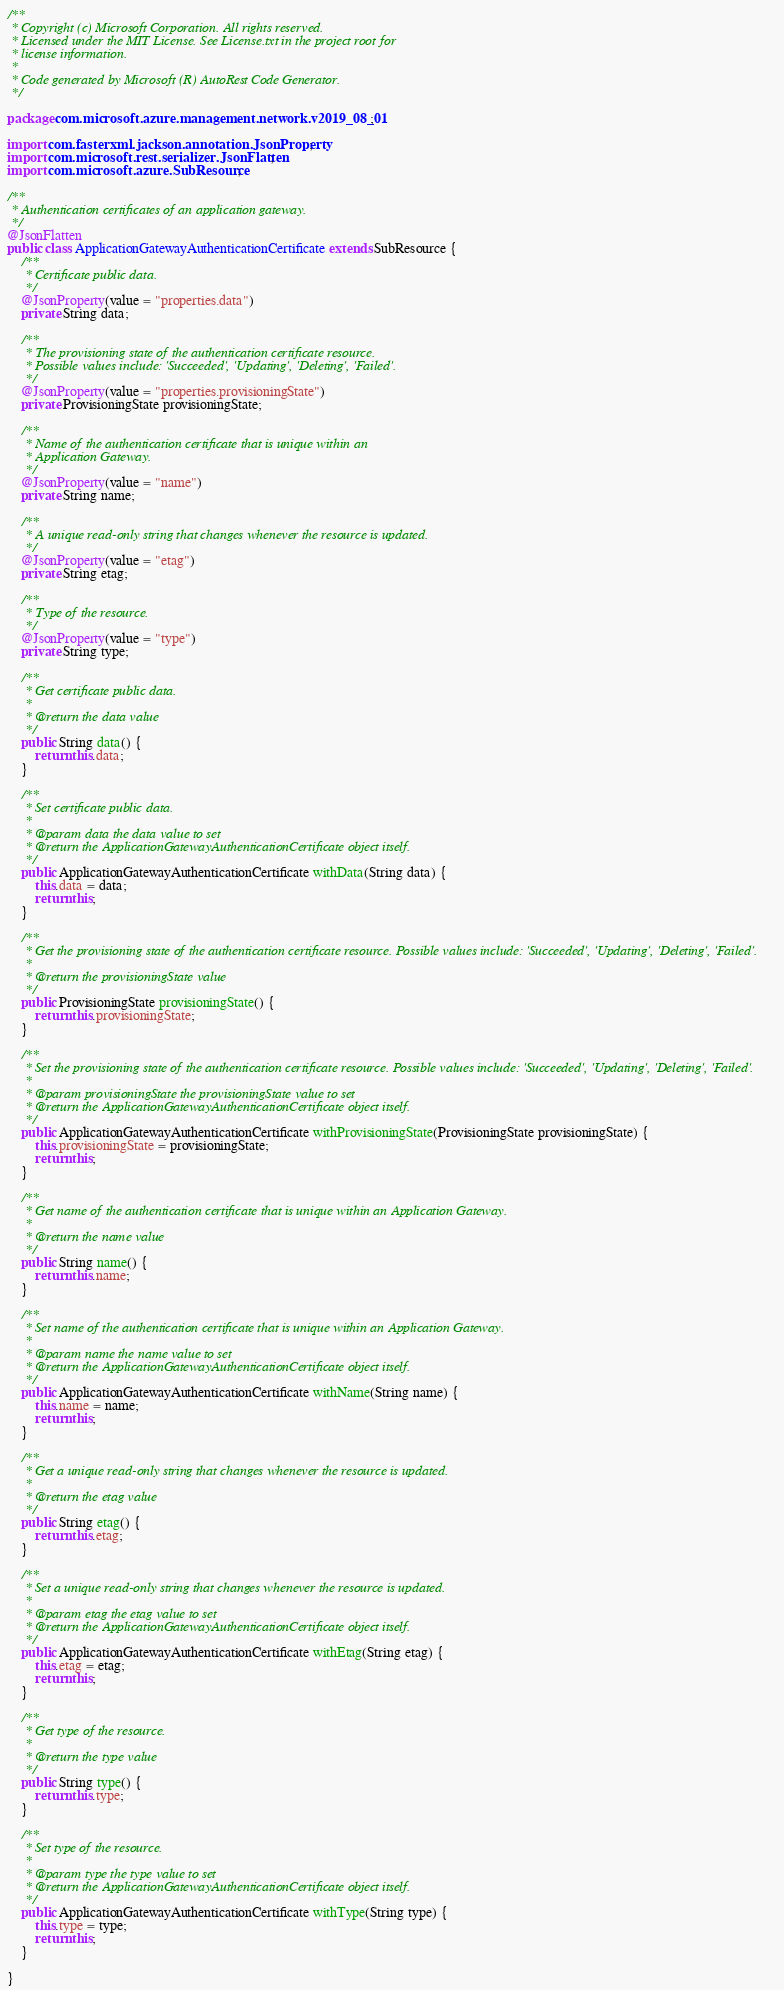<code> <loc_0><loc_0><loc_500><loc_500><_Java_>/**
 * Copyright (c) Microsoft Corporation. All rights reserved.
 * Licensed under the MIT License. See License.txt in the project root for
 * license information.
 *
 * Code generated by Microsoft (R) AutoRest Code Generator.
 */

package com.microsoft.azure.management.network.v2019_08_01;

import com.fasterxml.jackson.annotation.JsonProperty;
import com.microsoft.rest.serializer.JsonFlatten;
import com.microsoft.azure.SubResource;

/**
 * Authentication certificates of an application gateway.
 */
@JsonFlatten
public class ApplicationGatewayAuthenticationCertificate extends SubResource {
    /**
     * Certificate public data.
     */
    @JsonProperty(value = "properties.data")
    private String data;

    /**
     * The provisioning state of the authentication certificate resource.
     * Possible values include: 'Succeeded', 'Updating', 'Deleting', 'Failed'.
     */
    @JsonProperty(value = "properties.provisioningState")
    private ProvisioningState provisioningState;

    /**
     * Name of the authentication certificate that is unique within an
     * Application Gateway.
     */
    @JsonProperty(value = "name")
    private String name;

    /**
     * A unique read-only string that changes whenever the resource is updated.
     */
    @JsonProperty(value = "etag")
    private String etag;

    /**
     * Type of the resource.
     */
    @JsonProperty(value = "type")
    private String type;

    /**
     * Get certificate public data.
     *
     * @return the data value
     */
    public String data() {
        return this.data;
    }

    /**
     * Set certificate public data.
     *
     * @param data the data value to set
     * @return the ApplicationGatewayAuthenticationCertificate object itself.
     */
    public ApplicationGatewayAuthenticationCertificate withData(String data) {
        this.data = data;
        return this;
    }

    /**
     * Get the provisioning state of the authentication certificate resource. Possible values include: 'Succeeded', 'Updating', 'Deleting', 'Failed'.
     *
     * @return the provisioningState value
     */
    public ProvisioningState provisioningState() {
        return this.provisioningState;
    }

    /**
     * Set the provisioning state of the authentication certificate resource. Possible values include: 'Succeeded', 'Updating', 'Deleting', 'Failed'.
     *
     * @param provisioningState the provisioningState value to set
     * @return the ApplicationGatewayAuthenticationCertificate object itself.
     */
    public ApplicationGatewayAuthenticationCertificate withProvisioningState(ProvisioningState provisioningState) {
        this.provisioningState = provisioningState;
        return this;
    }

    /**
     * Get name of the authentication certificate that is unique within an Application Gateway.
     *
     * @return the name value
     */
    public String name() {
        return this.name;
    }

    /**
     * Set name of the authentication certificate that is unique within an Application Gateway.
     *
     * @param name the name value to set
     * @return the ApplicationGatewayAuthenticationCertificate object itself.
     */
    public ApplicationGatewayAuthenticationCertificate withName(String name) {
        this.name = name;
        return this;
    }

    /**
     * Get a unique read-only string that changes whenever the resource is updated.
     *
     * @return the etag value
     */
    public String etag() {
        return this.etag;
    }

    /**
     * Set a unique read-only string that changes whenever the resource is updated.
     *
     * @param etag the etag value to set
     * @return the ApplicationGatewayAuthenticationCertificate object itself.
     */
    public ApplicationGatewayAuthenticationCertificate withEtag(String etag) {
        this.etag = etag;
        return this;
    }

    /**
     * Get type of the resource.
     *
     * @return the type value
     */
    public String type() {
        return this.type;
    }

    /**
     * Set type of the resource.
     *
     * @param type the type value to set
     * @return the ApplicationGatewayAuthenticationCertificate object itself.
     */
    public ApplicationGatewayAuthenticationCertificate withType(String type) {
        this.type = type;
        return this;
    }

}
</code> 